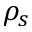<formula> <loc_0><loc_0><loc_500><loc_500>\rho _ { s }</formula> 